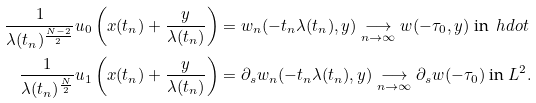Convert formula to latex. <formula><loc_0><loc_0><loc_500><loc_500>\frac { 1 } { \lambda ( t _ { n } ) ^ { \frac { N - 2 } { 2 } } } u _ { 0 } \left ( x ( t _ { n } ) + \frac { y } { \lambda ( t _ { n } ) } \right ) & = w _ { n } ( - t _ { n } \lambda ( t _ { n } ) , y ) \underset { n \rightarrow \infty } { \longrightarrow } w ( - \tau _ { 0 } , y ) \text { in } \ h d o t \\ \frac { 1 } { \lambda ( t _ { n } ) ^ { \frac { N } { 2 } } } u _ { 1 } \left ( x ( t _ { n } ) + \frac { y } { \lambda ( t _ { n } ) } \right ) & = \partial _ { s } w _ { n } ( - t _ { n } \lambda ( t _ { n } ) , y ) \underset { n \rightarrow \infty } { \longrightarrow } \partial _ { s } w ( - \tau _ { 0 } ) \text { in } L ^ { 2 } .</formula> 